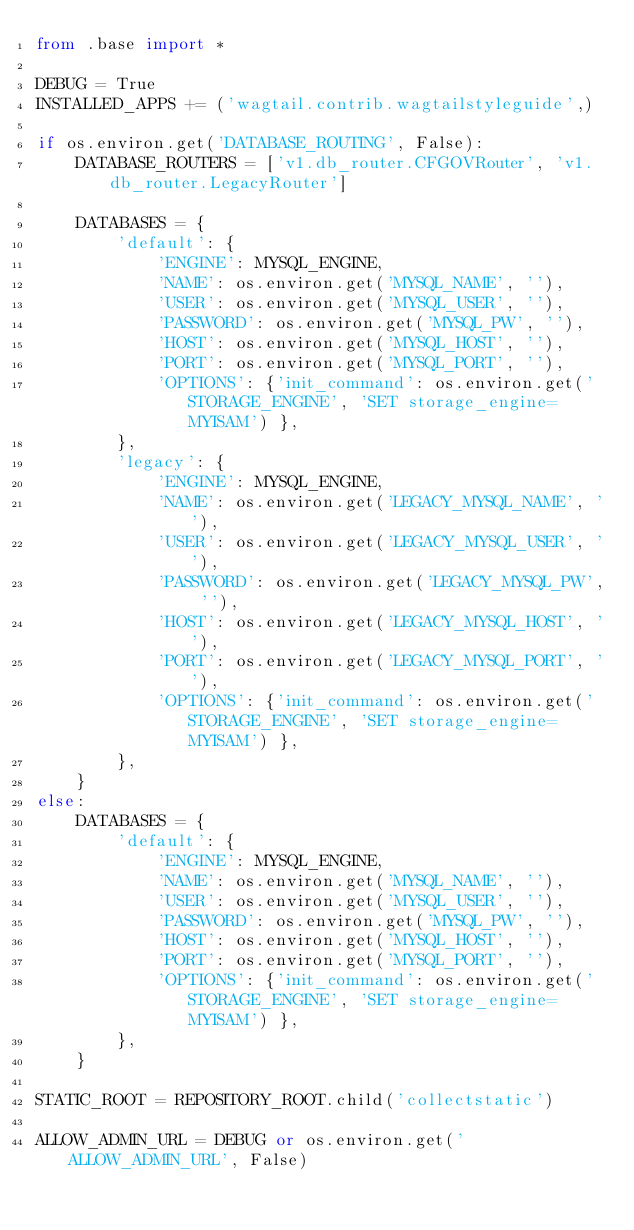Convert code to text. <code><loc_0><loc_0><loc_500><loc_500><_Python_>from .base import *

DEBUG = True
INSTALLED_APPS += ('wagtail.contrib.wagtailstyleguide',)

if os.environ.get('DATABASE_ROUTING', False):
    DATABASE_ROUTERS = ['v1.db_router.CFGOVRouter', 'v1.db_router.LegacyRouter']

    DATABASES = {
        'default': {
            'ENGINE': MYSQL_ENGINE,
            'NAME': os.environ.get('MYSQL_NAME', ''),
            'USER': os.environ.get('MYSQL_USER', ''),
            'PASSWORD': os.environ.get('MYSQL_PW', ''),
            'HOST': os.environ.get('MYSQL_HOST', ''),
            'PORT': os.environ.get('MYSQL_PORT', ''),
            'OPTIONS': {'init_command': os.environ.get('STORAGE_ENGINE', 'SET storage_engine=MYISAM') },
        },
        'legacy': {
            'ENGINE': MYSQL_ENGINE,
            'NAME': os.environ.get('LEGACY_MYSQL_NAME', ''),
            'USER': os.environ.get('LEGACY_MYSQL_USER', ''),
            'PASSWORD': os.environ.get('LEGACY_MYSQL_PW', ''),
            'HOST': os.environ.get('LEGACY_MYSQL_HOST', ''),
            'PORT': os.environ.get('LEGACY_MYSQL_PORT', ''),
            'OPTIONS': {'init_command': os.environ.get('STORAGE_ENGINE', 'SET storage_engine=MYISAM') },
        },
    }
else:
    DATABASES = {
        'default': {
            'ENGINE': MYSQL_ENGINE,
            'NAME': os.environ.get('MYSQL_NAME', ''),
            'USER': os.environ.get('MYSQL_USER', ''),
            'PASSWORD': os.environ.get('MYSQL_PW', ''),
            'HOST': os.environ.get('MYSQL_HOST', ''),
            'PORT': os.environ.get('MYSQL_PORT', ''),
            'OPTIONS': {'init_command': os.environ.get('STORAGE_ENGINE', 'SET storage_engine=MYISAM') },
        },
    }

STATIC_ROOT = REPOSITORY_ROOT.child('collectstatic')

ALLOW_ADMIN_URL = DEBUG or os.environ.get('ALLOW_ADMIN_URL', False)
</code> 